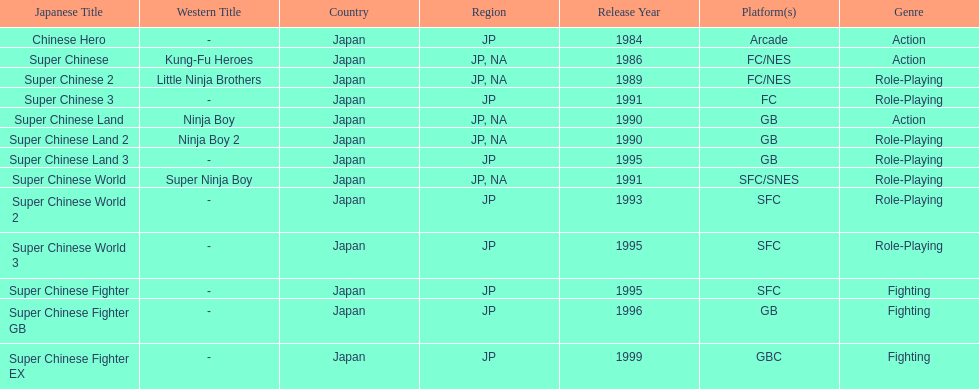How many action games were released in north america? 2. 